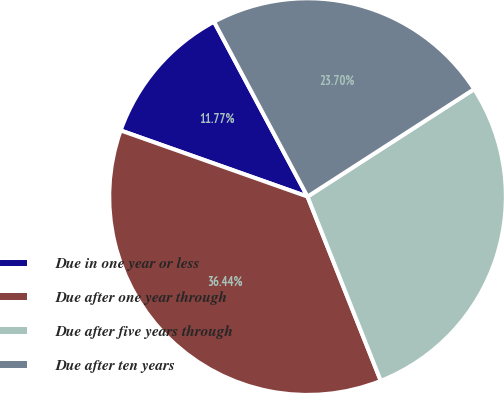<chart> <loc_0><loc_0><loc_500><loc_500><pie_chart><fcel>Due in one year or less<fcel>Due after one year through<fcel>Due after five years through<fcel>Due after ten years<nl><fcel>11.77%<fcel>36.44%<fcel>28.1%<fcel>23.7%<nl></chart> 